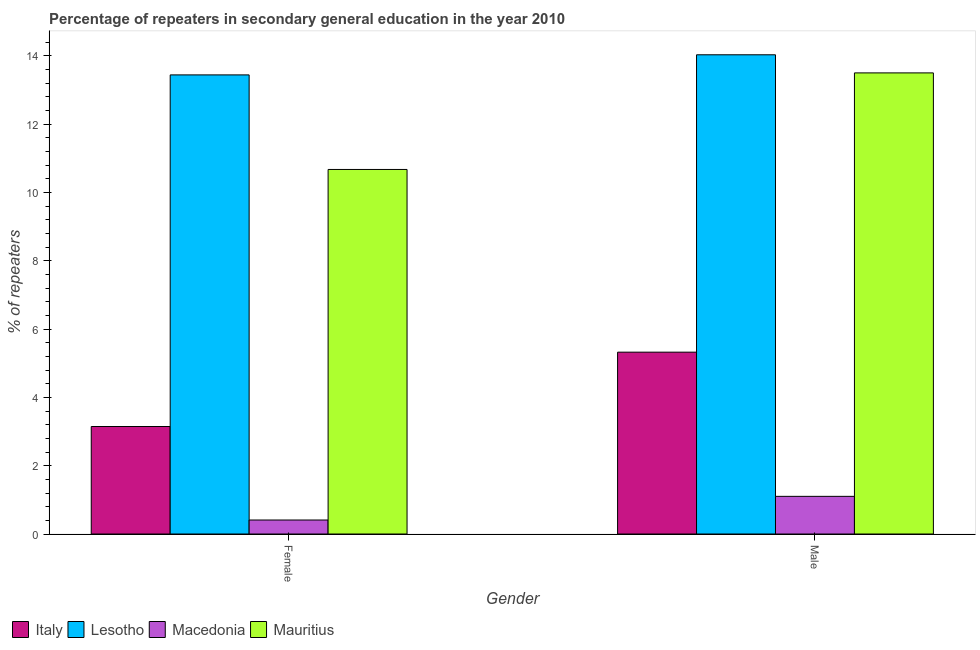How many groups of bars are there?
Offer a very short reply. 2. What is the label of the 1st group of bars from the left?
Make the answer very short. Female. What is the percentage of male repeaters in Mauritius?
Offer a very short reply. 13.5. Across all countries, what is the maximum percentage of female repeaters?
Your answer should be very brief. 13.44. Across all countries, what is the minimum percentage of female repeaters?
Make the answer very short. 0.41. In which country was the percentage of male repeaters maximum?
Your answer should be very brief. Lesotho. In which country was the percentage of male repeaters minimum?
Give a very brief answer. Macedonia. What is the total percentage of male repeaters in the graph?
Provide a succinct answer. 33.95. What is the difference between the percentage of female repeaters in Italy and that in Macedonia?
Provide a short and direct response. 2.74. What is the difference between the percentage of female repeaters in Mauritius and the percentage of male repeaters in Lesotho?
Your answer should be compact. -3.36. What is the average percentage of male repeaters per country?
Offer a very short reply. 8.49. What is the difference between the percentage of male repeaters and percentage of female repeaters in Lesotho?
Offer a terse response. 0.59. What is the ratio of the percentage of female repeaters in Mauritius to that in Lesotho?
Keep it short and to the point. 0.79. Is the percentage of male repeaters in Lesotho less than that in Italy?
Offer a terse response. No. In how many countries, is the percentage of female repeaters greater than the average percentage of female repeaters taken over all countries?
Ensure brevity in your answer.  2. What does the 1st bar from the right in Male represents?
Your response must be concise. Mauritius. Are all the bars in the graph horizontal?
Your response must be concise. No. How many countries are there in the graph?
Offer a terse response. 4. Are the values on the major ticks of Y-axis written in scientific E-notation?
Give a very brief answer. No. Does the graph contain any zero values?
Provide a succinct answer. No. What is the title of the graph?
Offer a terse response. Percentage of repeaters in secondary general education in the year 2010. What is the label or title of the X-axis?
Offer a very short reply. Gender. What is the label or title of the Y-axis?
Make the answer very short. % of repeaters. What is the % of repeaters of Italy in Female?
Provide a succinct answer. 3.15. What is the % of repeaters in Lesotho in Female?
Provide a short and direct response. 13.44. What is the % of repeaters of Macedonia in Female?
Provide a short and direct response. 0.41. What is the % of repeaters in Mauritius in Female?
Provide a succinct answer. 10.67. What is the % of repeaters of Italy in Male?
Your answer should be very brief. 5.32. What is the % of repeaters in Lesotho in Male?
Make the answer very short. 14.03. What is the % of repeaters of Macedonia in Male?
Your answer should be very brief. 1.1. What is the % of repeaters in Mauritius in Male?
Give a very brief answer. 13.5. Across all Gender, what is the maximum % of repeaters in Italy?
Provide a succinct answer. 5.32. Across all Gender, what is the maximum % of repeaters in Lesotho?
Give a very brief answer. 14.03. Across all Gender, what is the maximum % of repeaters of Macedonia?
Offer a terse response. 1.1. Across all Gender, what is the maximum % of repeaters in Mauritius?
Provide a succinct answer. 13.5. Across all Gender, what is the minimum % of repeaters in Italy?
Your response must be concise. 3.15. Across all Gender, what is the minimum % of repeaters in Lesotho?
Provide a short and direct response. 13.44. Across all Gender, what is the minimum % of repeaters in Macedonia?
Your answer should be very brief. 0.41. Across all Gender, what is the minimum % of repeaters in Mauritius?
Your response must be concise. 10.67. What is the total % of repeaters in Italy in the graph?
Give a very brief answer. 8.47. What is the total % of repeaters in Lesotho in the graph?
Your answer should be compact. 27.47. What is the total % of repeaters in Macedonia in the graph?
Your response must be concise. 1.51. What is the total % of repeaters in Mauritius in the graph?
Ensure brevity in your answer.  24.17. What is the difference between the % of repeaters in Italy in Female and that in Male?
Make the answer very short. -2.18. What is the difference between the % of repeaters of Lesotho in Female and that in Male?
Provide a short and direct response. -0.59. What is the difference between the % of repeaters of Macedonia in Female and that in Male?
Offer a terse response. -0.69. What is the difference between the % of repeaters of Mauritius in Female and that in Male?
Give a very brief answer. -2.83. What is the difference between the % of repeaters of Italy in Female and the % of repeaters of Lesotho in Male?
Make the answer very short. -10.88. What is the difference between the % of repeaters of Italy in Female and the % of repeaters of Macedonia in Male?
Your answer should be very brief. 2.04. What is the difference between the % of repeaters of Italy in Female and the % of repeaters of Mauritius in Male?
Provide a succinct answer. -10.35. What is the difference between the % of repeaters in Lesotho in Female and the % of repeaters in Macedonia in Male?
Your response must be concise. 12.34. What is the difference between the % of repeaters of Lesotho in Female and the % of repeaters of Mauritius in Male?
Provide a short and direct response. -0.06. What is the difference between the % of repeaters of Macedonia in Female and the % of repeaters of Mauritius in Male?
Offer a terse response. -13.09. What is the average % of repeaters of Italy per Gender?
Provide a succinct answer. 4.24. What is the average % of repeaters in Lesotho per Gender?
Your answer should be compact. 13.73. What is the average % of repeaters of Macedonia per Gender?
Provide a short and direct response. 0.76. What is the average % of repeaters in Mauritius per Gender?
Your answer should be very brief. 12.09. What is the difference between the % of repeaters of Italy and % of repeaters of Lesotho in Female?
Provide a short and direct response. -10.29. What is the difference between the % of repeaters in Italy and % of repeaters in Macedonia in Female?
Your answer should be very brief. 2.74. What is the difference between the % of repeaters in Italy and % of repeaters in Mauritius in Female?
Offer a very short reply. -7.53. What is the difference between the % of repeaters in Lesotho and % of repeaters in Macedonia in Female?
Provide a succinct answer. 13.03. What is the difference between the % of repeaters of Lesotho and % of repeaters of Mauritius in Female?
Your answer should be very brief. 2.77. What is the difference between the % of repeaters of Macedonia and % of repeaters of Mauritius in Female?
Your answer should be compact. -10.26. What is the difference between the % of repeaters of Italy and % of repeaters of Lesotho in Male?
Ensure brevity in your answer.  -8.71. What is the difference between the % of repeaters in Italy and % of repeaters in Macedonia in Male?
Offer a very short reply. 4.22. What is the difference between the % of repeaters in Italy and % of repeaters in Mauritius in Male?
Provide a short and direct response. -8.18. What is the difference between the % of repeaters of Lesotho and % of repeaters of Macedonia in Male?
Offer a terse response. 12.93. What is the difference between the % of repeaters of Lesotho and % of repeaters of Mauritius in Male?
Your answer should be very brief. 0.53. What is the difference between the % of repeaters in Macedonia and % of repeaters in Mauritius in Male?
Provide a succinct answer. -12.4. What is the ratio of the % of repeaters of Italy in Female to that in Male?
Offer a very short reply. 0.59. What is the ratio of the % of repeaters of Lesotho in Female to that in Male?
Provide a succinct answer. 0.96. What is the ratio of the % of repeaters of Macedonia in Female to that in Male?
Ensure brevity in your answer.  0.37. What is the ratio of the % of repeaters in Mauritius in Female to that in Male?
Provide a succinct answer. 0.79. What is the difference between the highest and the second highest % of repeaters in Italy?
Provide a short and direct response. 2.18. What is the difference between the highest and the second highest % of repeaters in Lesotho?
Offer a terse response. 0.59. What is the difference between the highest and the second highest % of repeaters of Macedonia?
Provide a succinct answer. 0.69. What is the difference between the highest and the second highest % of repeaters of Mauritius?
Provide a succinct answer. 2.83. What is the difference between the highest and the lowest % of repeaters in Italy?
Offer a terse response. 2.18. What is the difference between the highest and the lowest % of repeaters of Lesotho?
Your answer should be compact. 0.59. What is the difference between the highest and the lowest % of repeaters in Macedonia?
Keep it short and to the point. 0.69. What is the difference between the highest and the lowest % of repeaters in Mauritius?
Offer a very short reply. 2.83. 